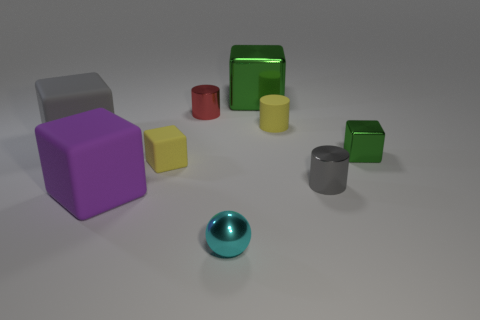Subtract all tiny green blocks. How many blocks are left? 4 Subtract all gray cubes. How many cubes are left? 4 Subtract all cyan cubes. Subtract all blue spheres. How many cubes are left? 5 Add 1 tiny green cubes. How many objects exist? 10 Subtract all cylinders. How many objects are left? 6 Subtract all tiny shiny objects. Subtract all metal balls. How many objects are left? 4 Add 9 tiny yellow cubes. How many tiny yellow cubes are left? 10 Add 3 yellow objects. How many yellow objects exist? 5 Subtract 1 red cylinders. How many objects are left? 8 